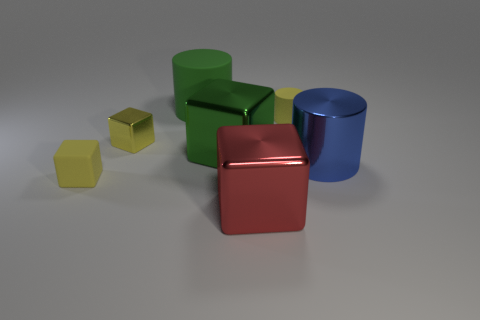How do the objects in the image relate to each other in size? In the image, there's a clear contrast in sizes among the objects. The red and green cubes are identical in size, being the largest objects shown. The blue cylinder is slightly smaller in height compared to these cubes, and the two smaller cubes, one yellow and the other yellow-green, are considerably smaller in scale. 